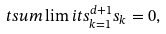<formula> <loc_0><loc_0><loc_500><loc_500>\ t s u m \lim i t s _ { k = 1 } ^ { d + 1 } s _ { k } = 0 ,</formula> 